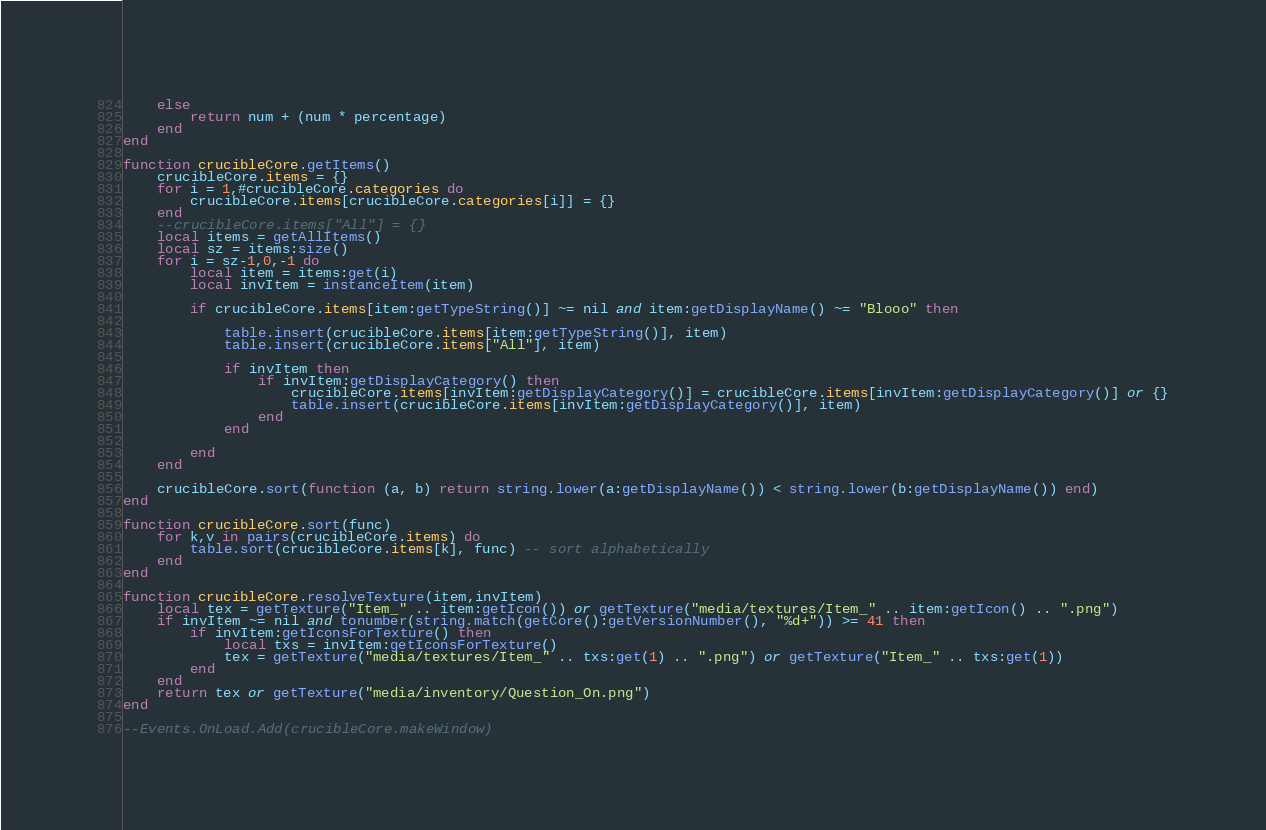Convert code to text. <code><loc_0><loc_0><loc_500><loc_500><_Lua_>	else
		return num + (num * percentage)
	end
end

function crucibleCore.getItems()
	crucibleCore.items = {}
	for i = 1,#crucibleCore.categories do
		crucibleCore.items[crucibleCore.categories[i]] = {}
	end
	--crucibleCore.items["All"] = {}
	local items = getAllItems()
	local sz = items:size()
	for i = sz-1,0,-1 do
		local item = items:get(i)
		local invItem = instanceItem(item)
		
		if crucibleCore.items[item:getTypeString()] ~= nil and item:getDisplayName() ~= "Blooo" then
		
			table.insert(crucibleCore.items[item:getTypeString()], item)
			table.insert(crucibleCore.items["All"], item)
			
			if invItem then
				if invItem:getDisplayCategory() then
					crucibleCore.items[invItem:getDisplayCategory()] = crucibleCore.items[invItem:getDisplayCategory()] or {}
					table.insert(crucibleCore.items[invItem:getDisplayCategory()], item)
				end
			end
			
		end
	end
	
	crucibleCore.sort(function (a, b) return string.lower(a:getDisplayName()) < string.lower(b:getDisplayName()) end)
end

function crucibleCore.sort(func)
	for k,v in pairs(crucibleCore.items) do
		table.sort(crucibleCore.items[k], func) -- sort alphabetically
	end
end

function crucibleCore.resolveTexture(item,invItem)
	local tex = getTexture("Item_" .. item:getIcon()) or getTexture("media/textures/Item_" .. item:getIcon() .. ".png")
	if invItem ~= nil and tonumber(string.match(getCore():getVersionNumber(), "%d+")) >= 41 then
		if invItem:getIconsForTexture() then
			local txs = invItem:getIconsForTexture()
			tex = getTexture("media/textures/Item_" .. txs:get(1) .. ".png") or getTexture("Item_" .. txs:get(1))
		end
	end
	return tex or getTexture("media/inventory/Question_On.png")
end

--Events.OnLoad.Add(crucibleCore.makeWindow)</code> 